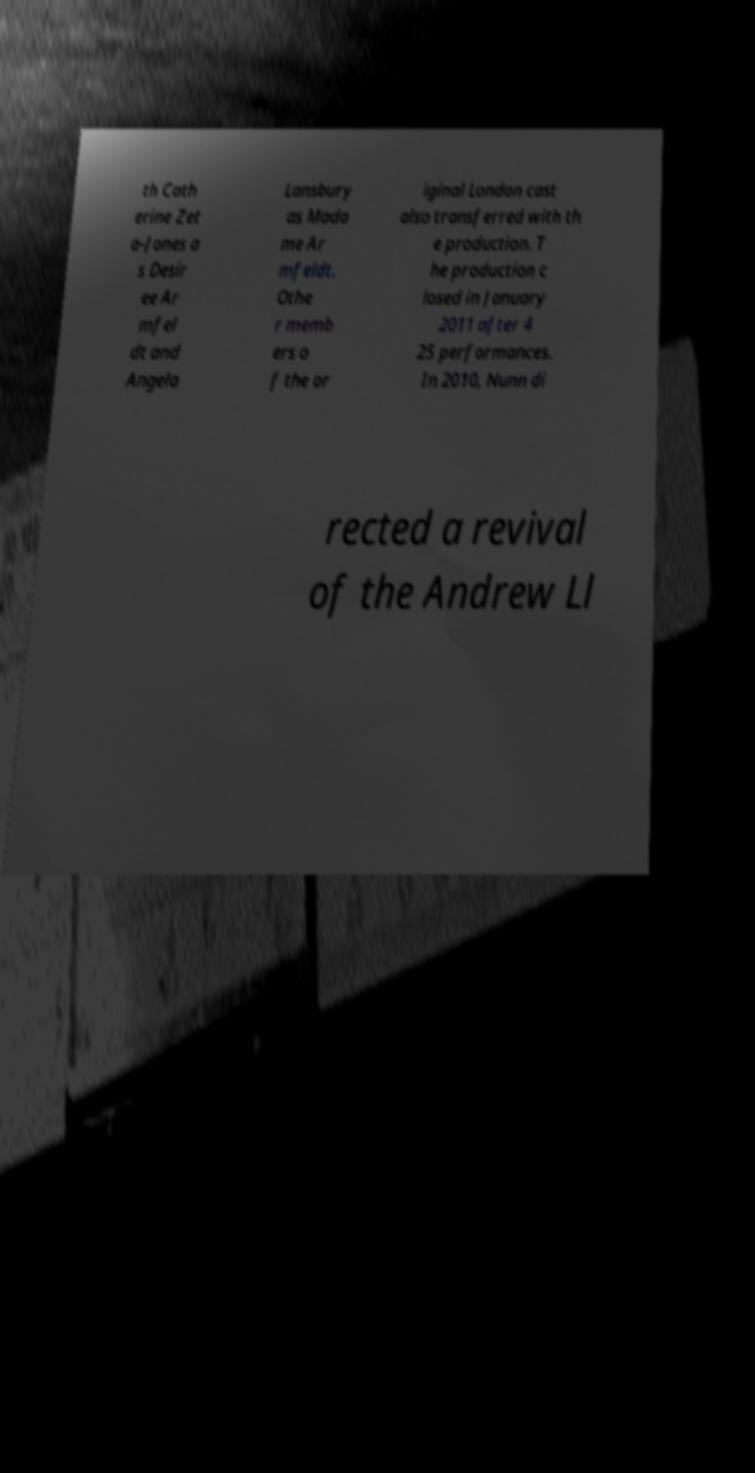Please read and relay the text visible in this image. What does it say? th Cath erine Zet a-Jones a s Desir ee Ar mfel dt and Angela Lansbury as Mada me Ar mfeldt. Othe r memb ers o f the or iginal London cast also transferred with th e production. T he production c losed in January 2011 after 4 25 performances. In 2010, Nunn di rected a revival of the Andrew Ll 